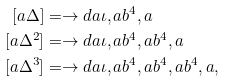Convert formula to latex. <formula><loc_0><loc_0><loc_500><loc_500>[ a \Delta ] & = \to d a { \iota , a b ^ { 4 } , a } \\ [ a \Delta ^ { 2 } ] & = \to d a { \iota , a b ^ { 4 } , a b ^ { 4 } , a } \\ [ a \Delta ^ { 3 } ] & = \to d a { \iota , a b ^ { 4 } , a b ^ { 4 } , a b ^ { 4 } , a } ,</formula> 